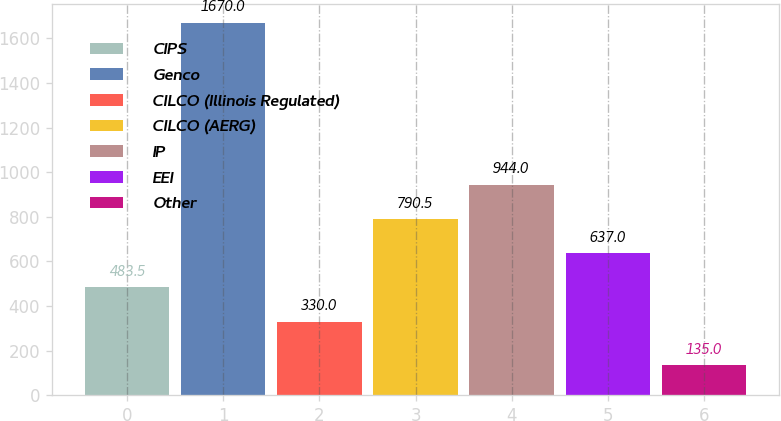<chart> <loc_0><loc_0><loc_500><loc_500><bar_chart><fcel>CIPS<fcel>Genco<fcel>CILCO (Illinois Regulated)<fcel>CILCO (AERG)<fcel>IP<fcel>EEI<fcel>Other<nl><fcel>483.5<fcel>1670<fcel>330<fcel>790.5<fcel>944<fcel>637<fcel>135<nl></chart> 